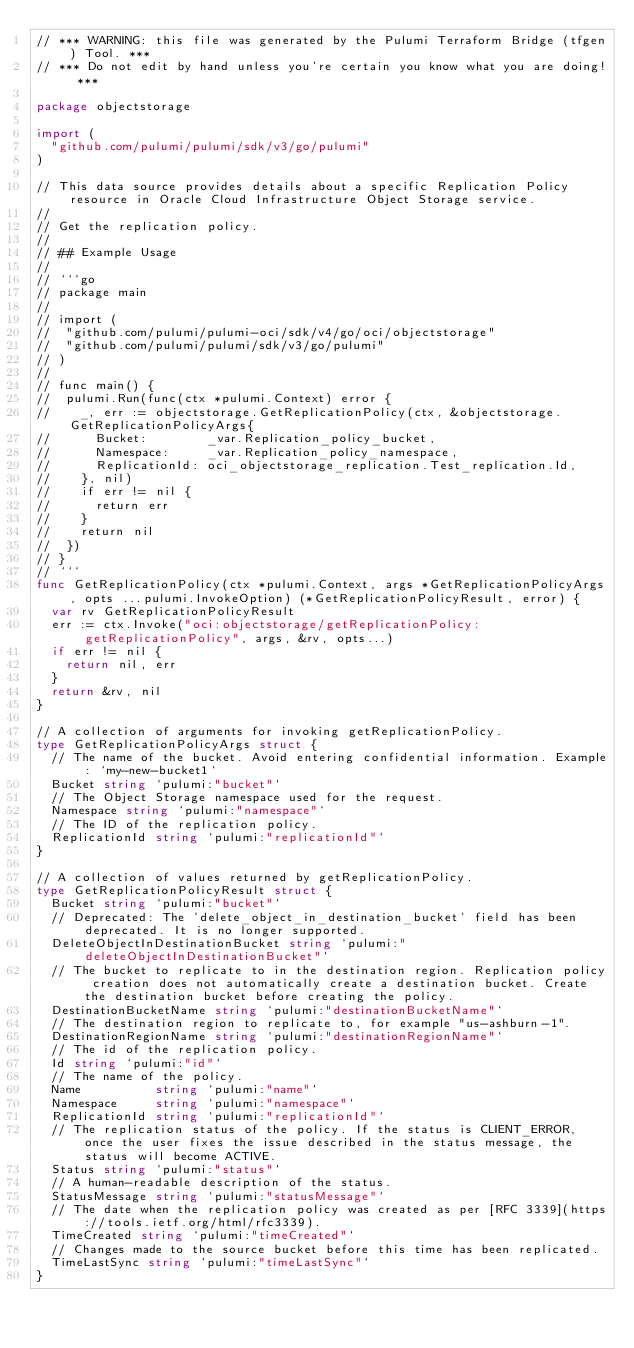<code> <loc_0><loc_0><loc_500><loc_500><_Go_>// *** WARNING: this file was generated by the Pulumi Terraform Bridge (tfgen) Tool. ***
// *** Do not edit by hand unless you're certain you know what you are doing! ***

package objectstorage

import (
	"github.com/pulumi/pulumi/sdk/v3/go/pulumi"
)

// This data source provides details about a specific Replication Policy resource in Oracle Cloud Infrastructure Object Storage service.
//
// Get the replication policy.
//
// ## Example Usage
//
// ```go
// package main
//
// import (
// 	"github.com/pulumi/pulumi-oci/sdk/v4/go/oci/objectstorage"
// 	"github.com/pulumi/pulumi/sdk/v3/go/pulumi"
// )
//
// func main() {
// 	pulumi.Run(func(ctx *pulumi.Context) error {
// 		_, err := objectstorage.GetReplicationPolicy(ctx, &objectstorage.GetReplicationPolicyArgs{
// 			Bucket:        _var.Replication_policy_bucket,
// 			Namespace:     _var.Replication_policy_namespace,
// 			ReplicationId: oci_objectstorage_replication.Test_replication.Id,
// 		}, nil)
// 		if err != nil {
// 			return err
// 		}
// 		return nil
// 	})
// }
// ```
func GetReplicationPolicy(ctx *pulumi.Context, args *GetReplicationPolicyArgs, opts ...pulumi.InvokeOption) (*GetReplicationPolicyResult, error) {
	var rv GetReplicationPolicyResult
	err := ctx.Invoke("oci:objectstorage/getReplicationPolicy:getReplicationPolicy", args, &rv, opts...)
	if err != nil {
		return nil, err
	}
	return &rv, nil
}

// A collection of arguments for invoking getReplicationPolicy.
type GetReplicationPolicyArgs struct {
	// The name of the bucket. Avoid entering confidential information. Example: `my-new-bucket1`
	Bucket string `pulumi:"bucket"`
	// The Object Storage namespace used for the request.
	Namespace string `pulumi:"namespace"`
	// The ID of the replication policy.
	ReplicationId string `pulumi:"replicationId"`
}

// A collection of values returned by getReplicationPolicy.
type GetReplicationPolicyResult struct {
	Bucket string `pulumi:"bucket"`
	// Deprecated: The 'delete_object_in_destination_bucket' field has been deprecated. It is no longer supported.
	DeleteObjectInDestinationBucket string `pulumi:"deleteObjectInDestinationBucket"`
	// The bucket to replicate to in the destination region. Replication policy creation does not automatically create a destination bucket. Create the destination bucket before creating the policy.
	DestinationBucketName string `pulumi:"destinationBucketName"`
	// The destination region to replicate to, for example "us-ashburn-1".
	DestinationRegionName string `pulumi:"destinationRegionName"`
	// The id of the replication policy.
	Id string `pulumi:"id"`
	// The name of the policy.
	Name          string `pulumi:"name"`
	Namespace     string `pulumi:"namespace"`
	ReplicationId string `pulumi:"replicationId"`
	// The replication status of the policy. If the status is CLIENT_ERROR, once the user fixes the issue described in the status message, the status will become ACTIVE.
	Status string `pulumi:"status"`
	// A human-readable description of the status.
	StatusMessage string `pulumi:"statusMessage"`
	// The date when the replication policy was created as per [RFC 3339](https://tools.ietf.org/html/rfc3339).
	TimeCreated string `pulumi:"timeCreated"`
	// Changes made to the source bucket before this time has been replicated.
	TimeLastSync string `pulumi:"timeLastSync"`
}
</code> 